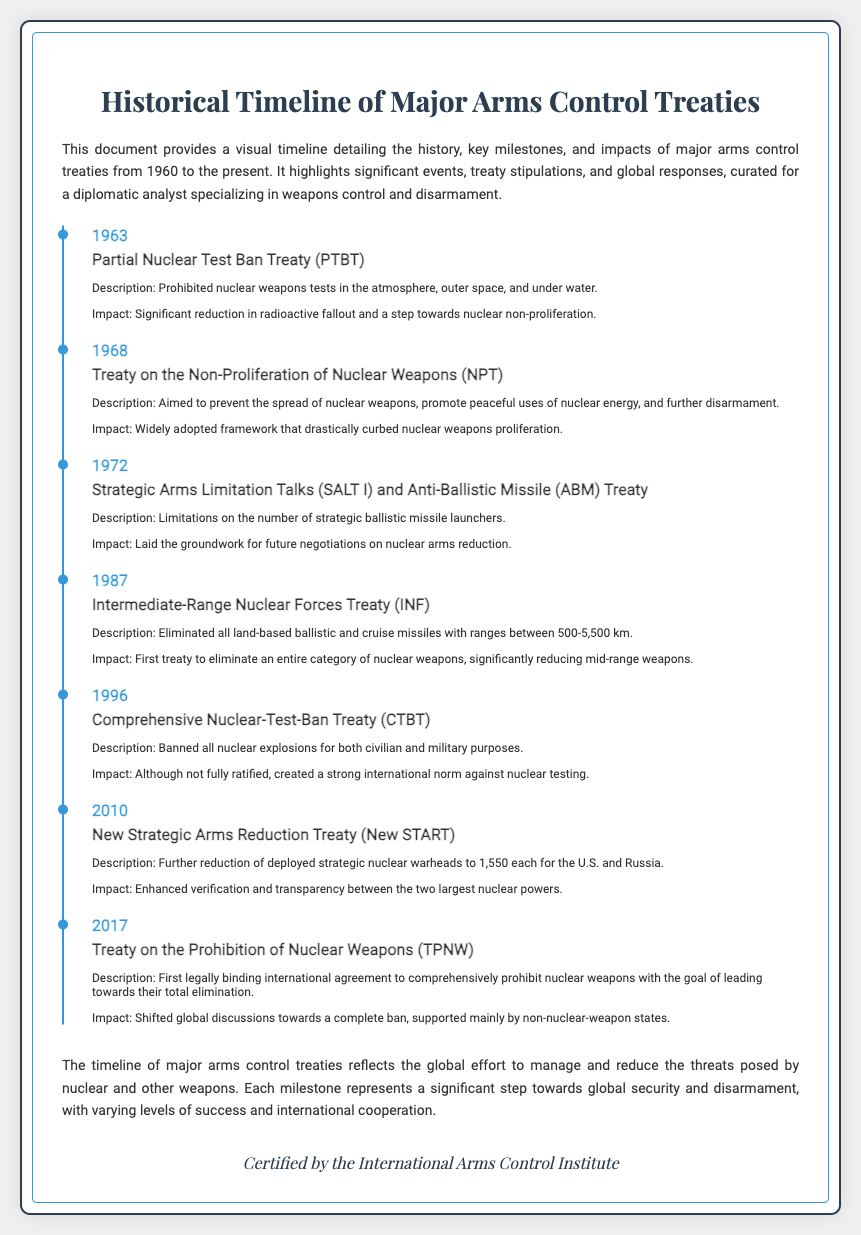what year was the Partial Nuclear Test Ban Treaty signed? The document lists the year when the Partial Nuclear Test Ban Treaty was signed as 1963.
Answer: 1963 what is the main goal of the Treaty on the Non-Proliferation of Nuclear Weapons? The document describes the main goal of the Treaty on the Non-Proliferation of Nuclear Weapons as preventing the spread of nuclear weapons.
Answer: Preventing the spread of nuclear weapons which treaty eliminated all land-based ballistic and cruise missiles with ranges between 500-5,500 km? The document states that the Intermediate-Range Nuclear Forces Treaty eliminated this category of missiles.
Answer: Intermediate-Range Nuclear Forces Treaty (INF) how many deployed strategic nuclear warheads are allowed under the New Strategic Arms Reduction Treaty? According to the document, the New Strategic Arms Reduction Treaty limits deployed strategic nuclear warheads to 1,550 for each of the U.S. and Russia.
Answer: 1,550 in which year was the Comprehensive Nuclear-Test-Ban Treaty introduced? The document lists 1996 as the year when the Comprehensive Nuclear-Test-Ban Treaty was introduced.
Answer: 1996 what impact did the Intermediate-Range Nuclear Forces Treaty have? The document indicates that it was the first treaty to eliminate an entire category of nuclear weapons, significantly reducing mid-range weapons.
Answer: Eliminated an entire category of nuclear weapons what is the significance of the Treaty on the Prohibition of Nuclear Weapons? The document mentions that it is the first legally binding international agreement to comprehensively prohibit nuclear weapons.
Answer: First legally binding international agreement how does the timeline reflect global efforts for disarmament? The document concludes that the timeline reflects significant steps towards global security and disarmament with varying success.
Answer: Significant steps towards global security and disarmament what organization certified the diploma? The document states that the diploma is certified by the International Arms Control Institute.
Answer: International Arms Control Institute 